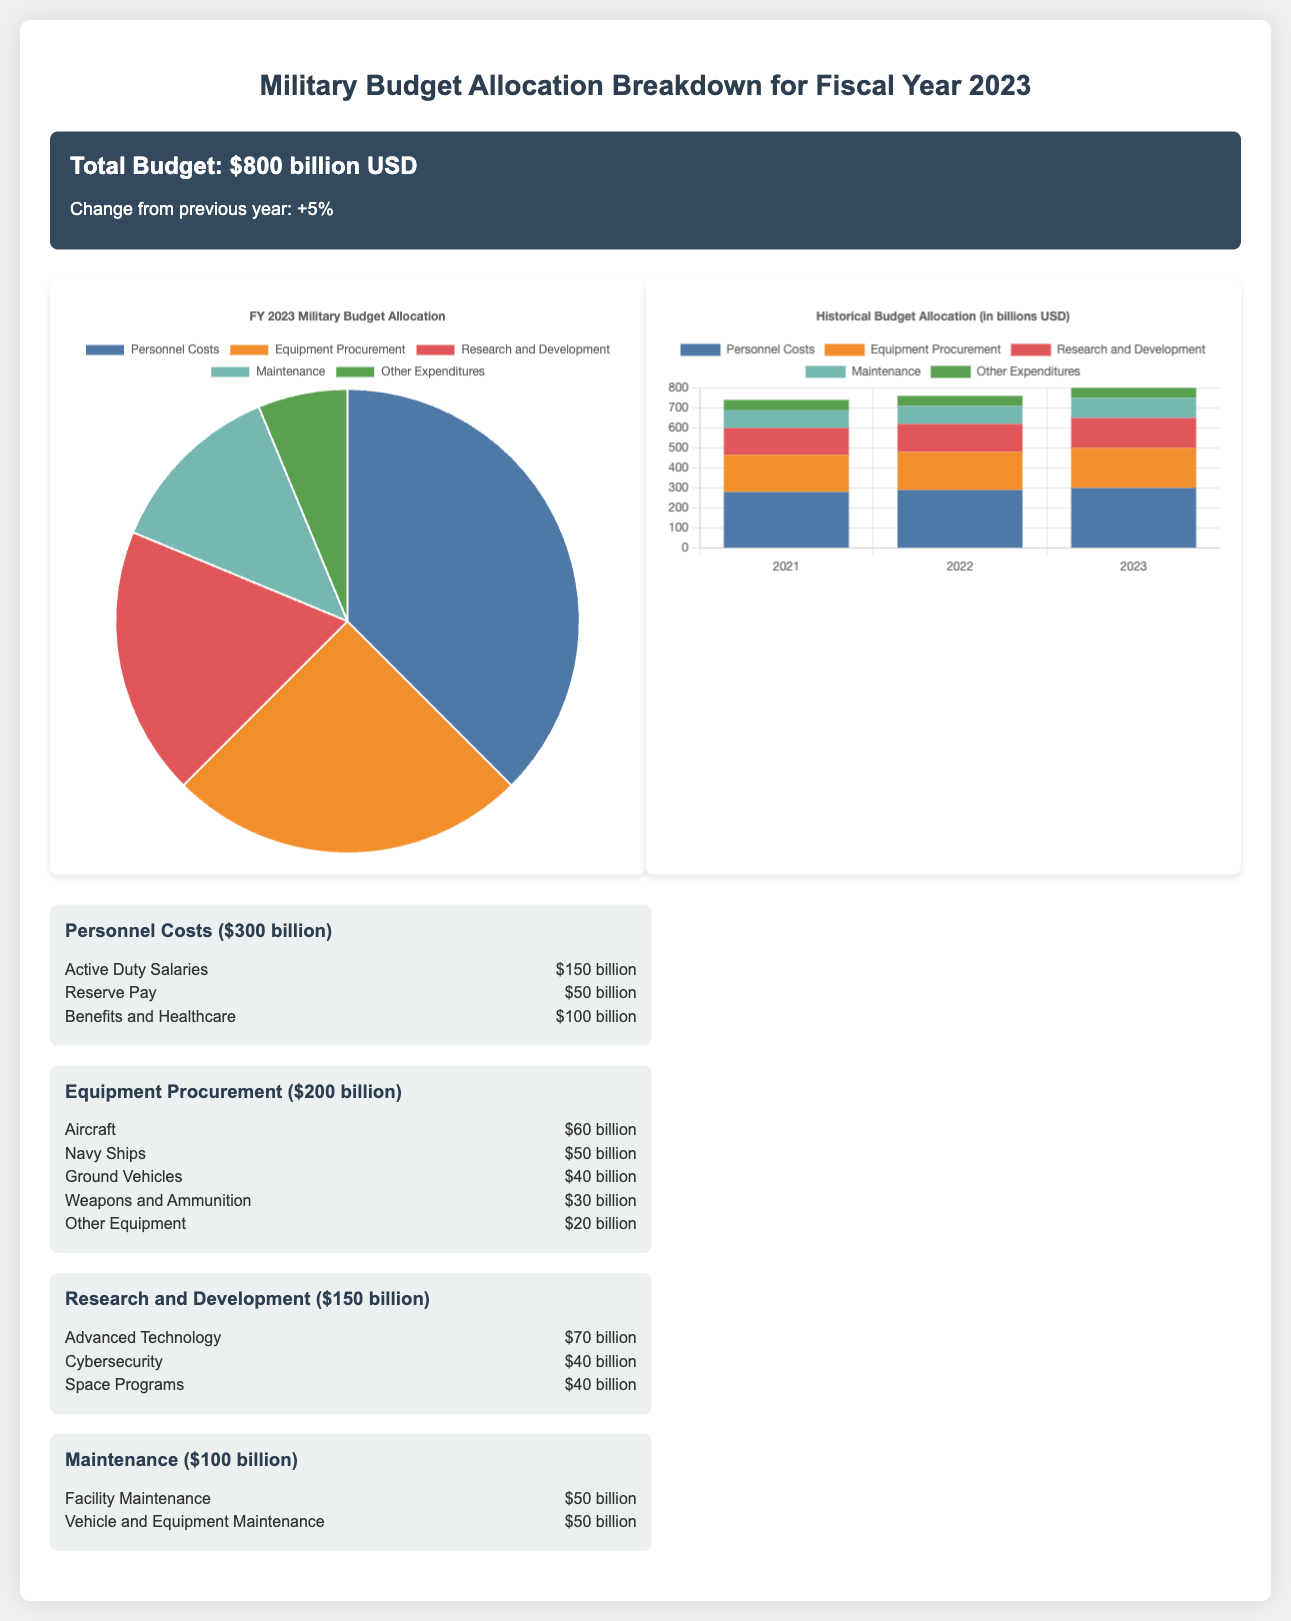What is the total military budget for Fiscal Year 2023? The total military budget is stated clearly at the top of the document, which is $800 billion USD.
Answer: $800 billion USD How much is allocated for personnel costs? The document provides a breakdown of the budget, and personnel costs are specifically listed as $300 billion.
Answer: $300 billion Which category has the highest budget allocation? By examining the budget breakdown, it is evident that personnel costs have the highest allocation compared to other categories.
Answer: Personnel Costs What was the percentage change in budget from the previous year? The document states that the change from the previous year is +5%, directly indicating the growth in the budget.
Answer: +5% How much is allocated to research and development? The budget section lists research and development costs at $150 billion, providing a clear figure.
Answer: $150 billion What funding is allocated for advanced technology in research and development? The document specifies that the allocation for advanced technology is $70 billion, which is part of the R&D category.
Answer: $70 billion How much funding was allocated for weapons and ammunition? The breakdown under equipment procurement indicates that funding for weapons and ammunition is $30 billion.
Answer: $30 billion What does the bar chart represent? The bar chart represents historical budget allocations for the years 2021, 2022, and 2023 across different categories, demonstrating changes over time.
Answer: Historical budget allocations What is the total allocated amount for maintenance? Maintenance costs are detailed in the budget breakdown, totaling $100 billion, including various subcategories specified in the document.
Answer: $100 billion 